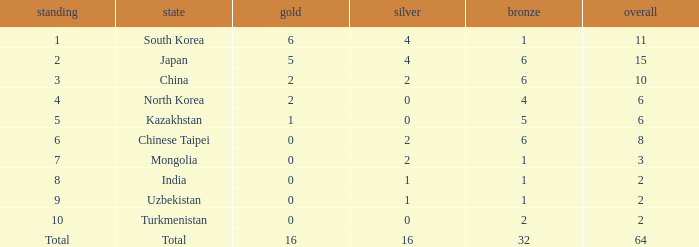What rank is Turkmenistan, who had 0 silver's and Less than 2 golds? 10.0. 